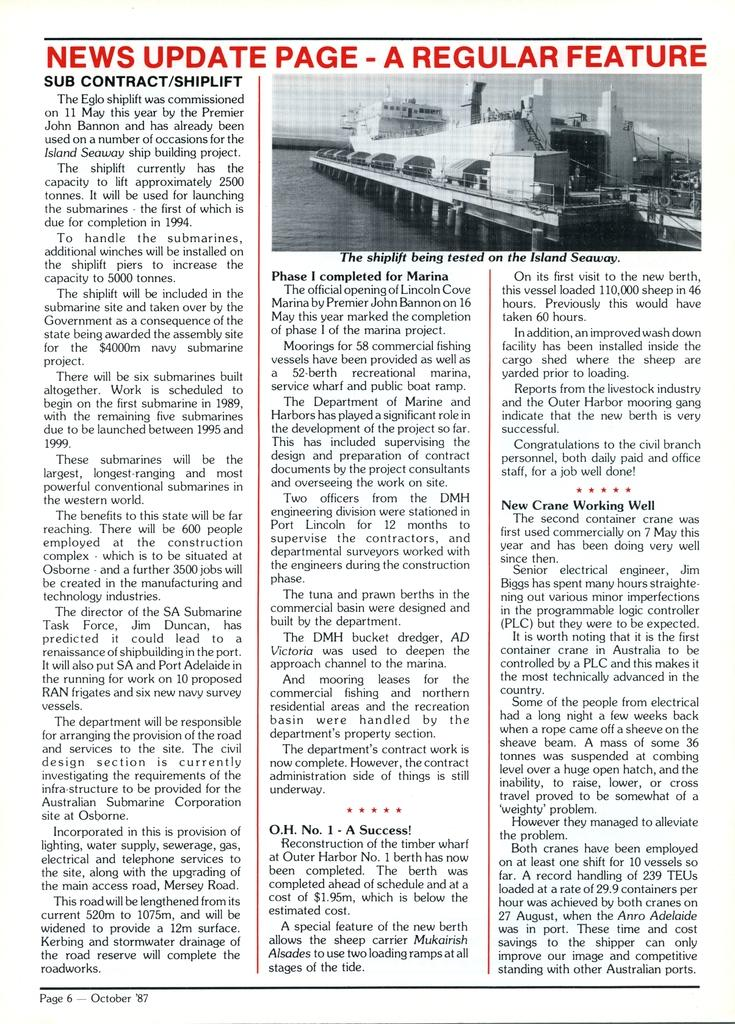<image>
Render a clear and concise summary of the photo. A print article featuring some new equipment on the St. Lawrence Seaway 